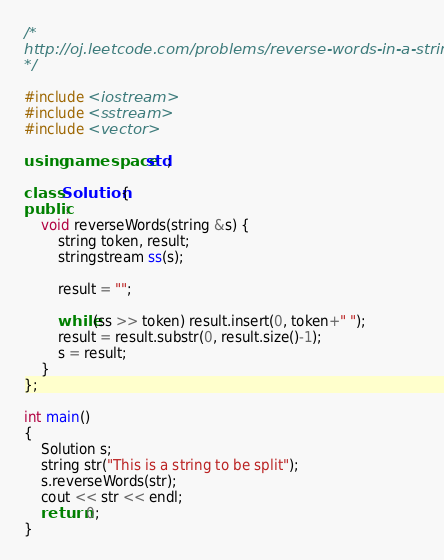<code> <loc_0><loc_0><loc_500><loc_500><_C++_>/*
http://oj.leetcode.com/problems/reverse-words-in-a-string/
*/

#include <iostream>
#include <sstream>
#include <vector>

using namespace std;

class Solution {
public:
    void reverseWords(string &s) {
        string token, result;
        stringstream ss(s);

        result = "";
        
        while(ss >> token) result.insert(0, token+" ");
        result = result.substr(0, result.size()-1);
        s = result;
    }
};

int main()
{
    Solution s;
    string str("This is a string to be split");
    s.reverseWords(str);
    cout << str << endl;
    return 0;
}</code> 